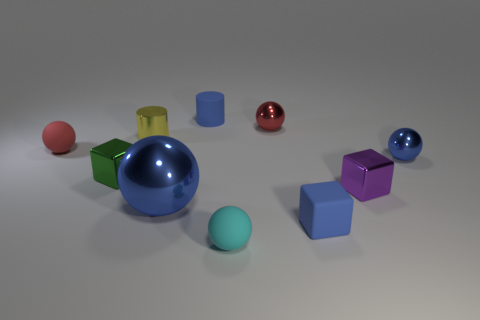Subtract all cyan blocks. How many red spheres are left? 2 Subtract all tiny shiny blocks. How many blocks are left? 1 Subtract 1 blocks. How many blocks are left? 2 Subtract all red spheres. How many spheres are left? 3 Subtract all purple balls. Subtract all red blocks. How many balls are left? 5 Subtract all cubes. How many objects are left? 7 Subtract 1 cyan balls. How many objects are left? 9 Subtract all large purple shiny objects. Subtract all small blue rubber cylinders. How many objects are left? 9 Add 4 small cubes. How many small cubes are left? 7 Add 3 tiny purple cylinders. How many tiny purple cylinders exist? 3 